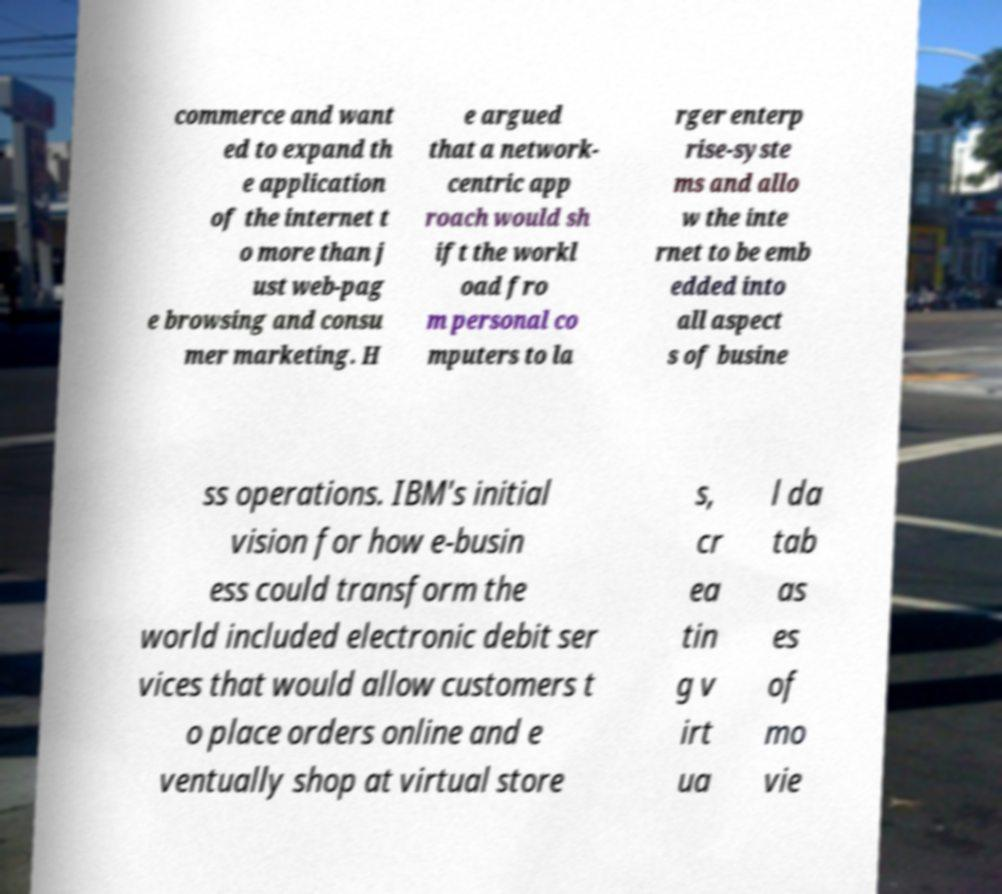There's text embedded in this image that I need extracted. Can you transcribe it verbatim? commerce and want ed to expand th e application of the internet t o more than j ust web-pag e browsing and consu mer marketing. H e argued that a network- centric app roach would sh ift the workl oad fro m personal co mputers to la rger enterp rise-syste ms and allo w the inte rnet to be emb edded into all aspect s of busine ss operations. IBM's initial vision for how e-busin ess could transform the world included electronic debit ser vices that would allow customers t o place orders online and e ventually shop at virtual store s, cr ea tin g v irt ua l da tab as es of mo vie 